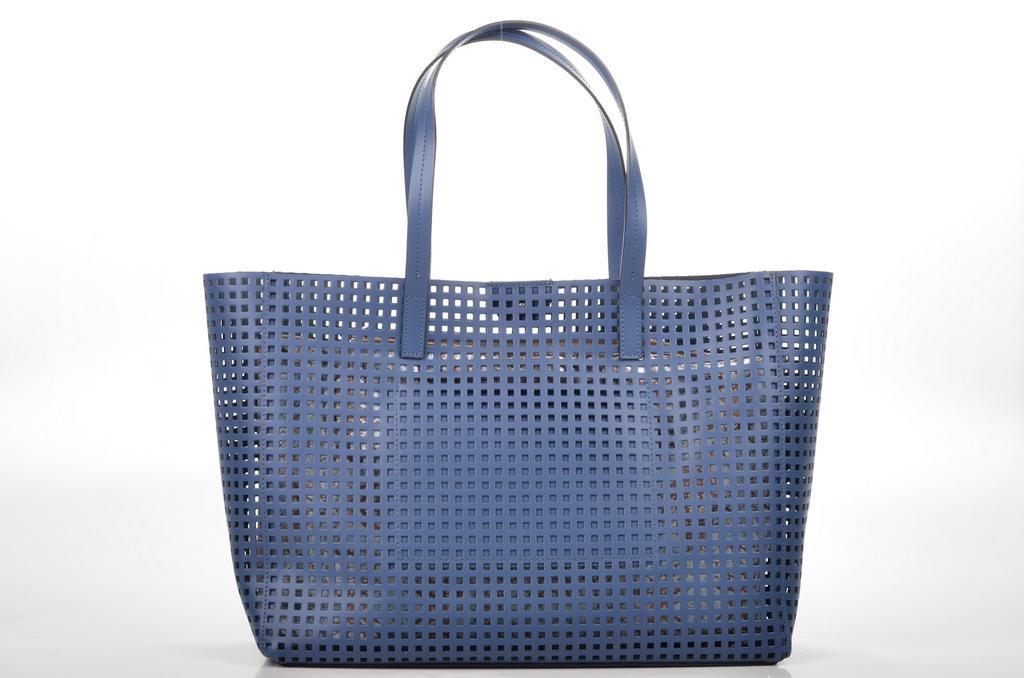Describe this image in one or two sentences. There is a blue colour hand bag. Which contains small holes in it. 